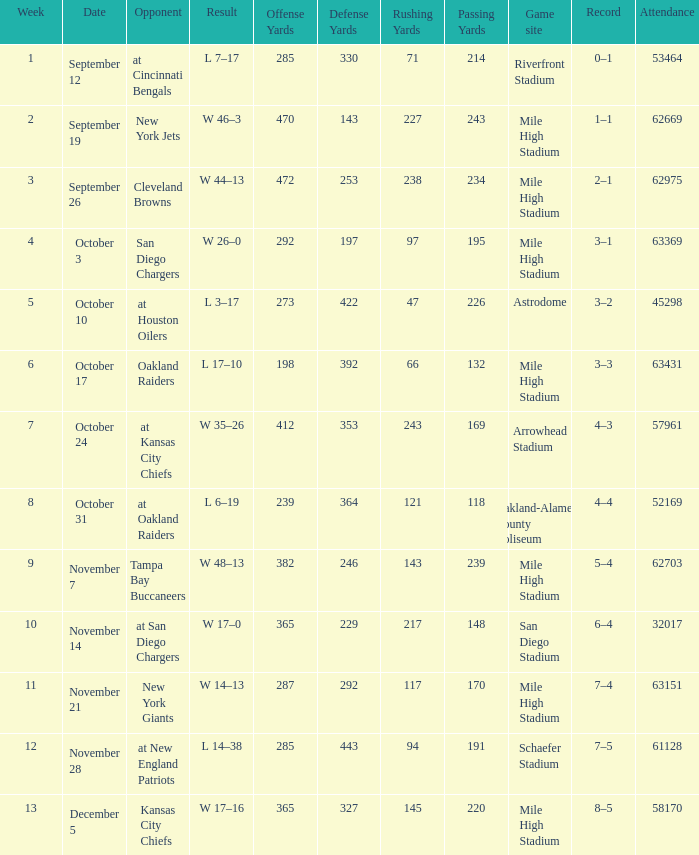What was the week number when the opponent was the New York Jets? 2.0. 